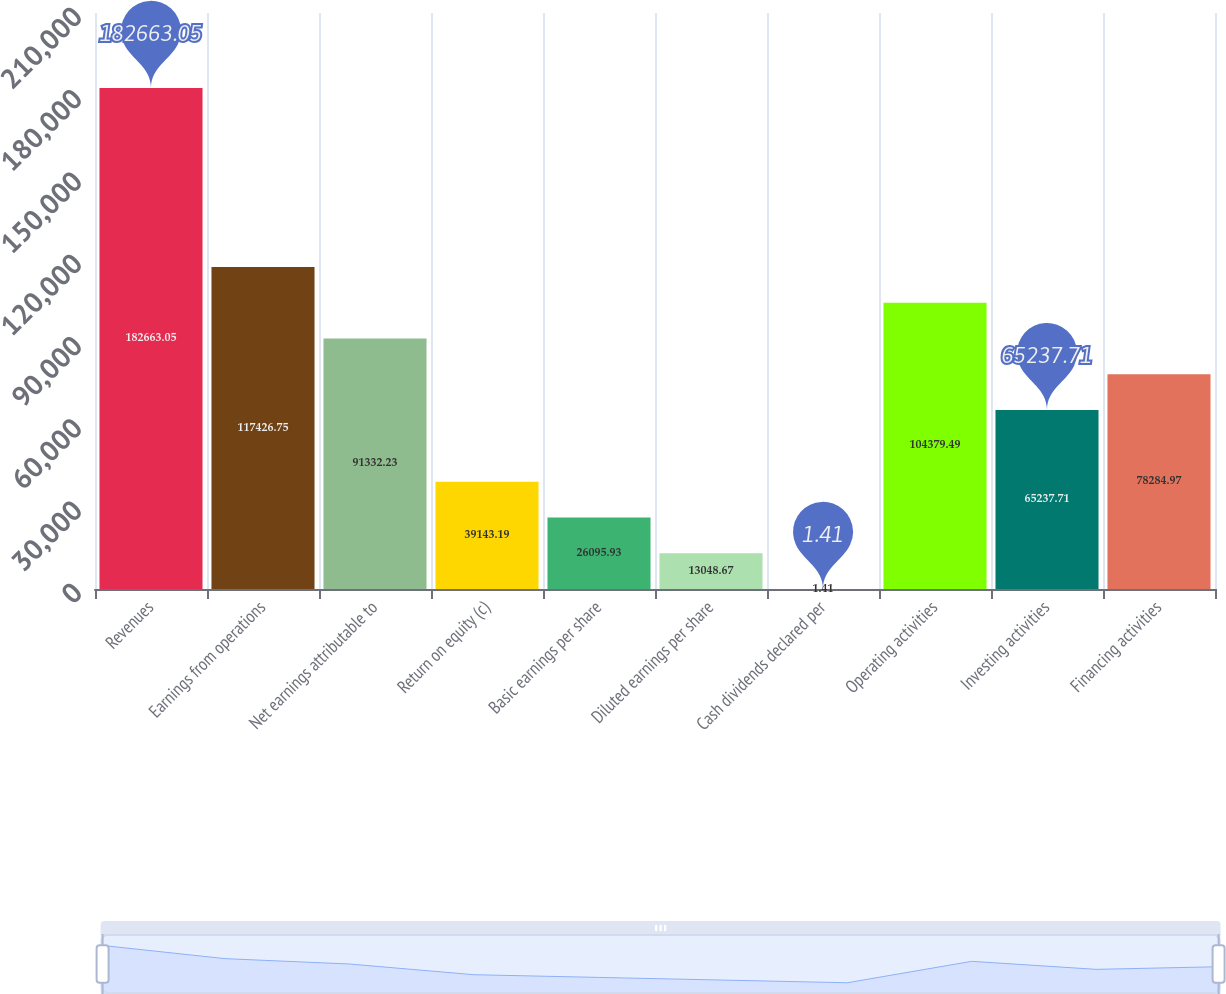Convert chart to OTSL. <chart><loc_0><loc_0><loc_500><loc_500><bar_chart><fcel>Revenues<fcel>Earnings from operations<fcel>Net earnings attributable to<fcel>Return on equity (c)<fcel>Basic earnings per share<fcel>Diluted earnings per share<fcel>Cash dividends declared per<fcel>Operating activities<fcel>Investing activities<fcel>Financing activities<nl><fcel>182663<fcel>117427<fcel>91332.2<fcel>39143.2<fcel>26095.9<fcel>13048.7<fcel>1.41<fcel>104379<fcel>65237.7<fcel>78285<nl></chart> 